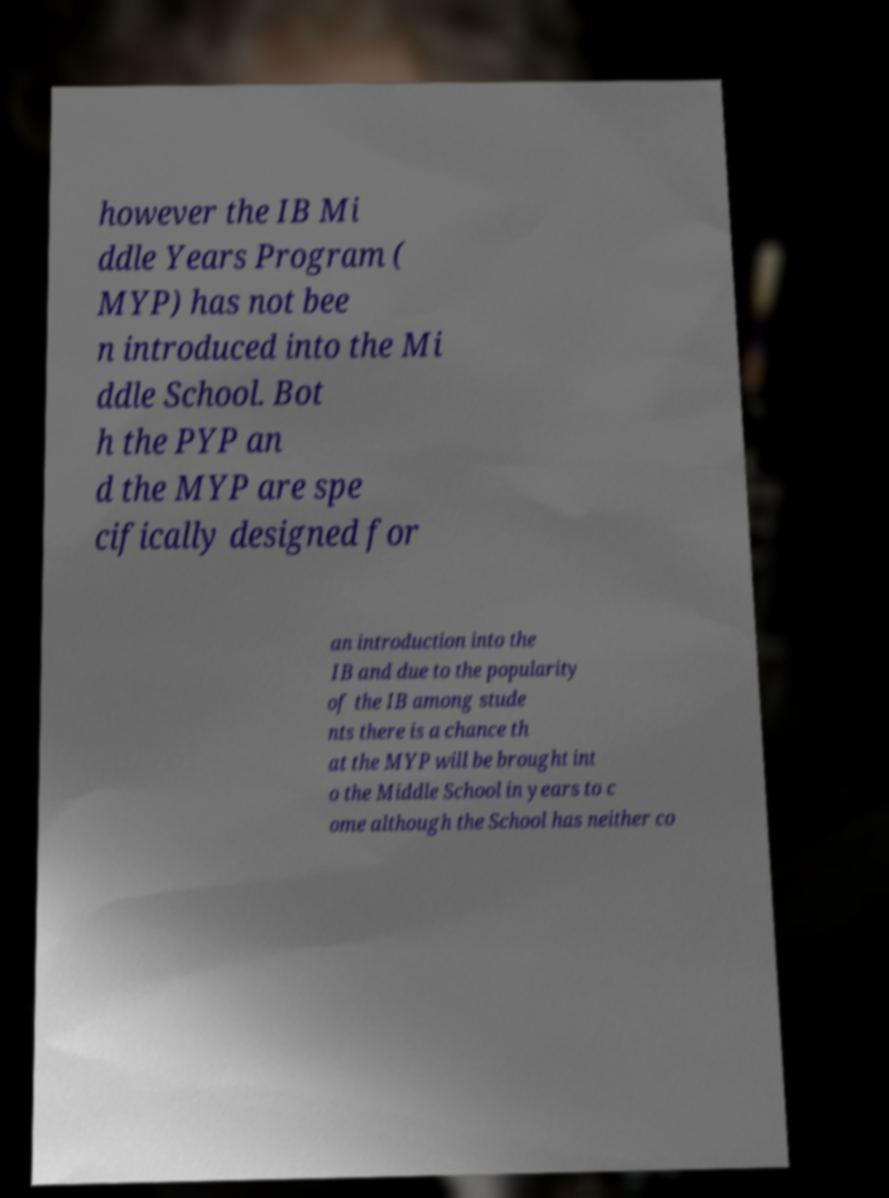Please read and relay the text visible in this image. What does it say? however the IB Mi ddle Years Program ( MYP) has not bee n introduced into the Mi ddle School. Bot h the PYP an d the MYP are spe cifically designed for an introduction into the IB and due to the popularity of the IB among stude nts there is a chance th at the MYP will be brought int o the Middle School in years to c ome although the School has neither co 